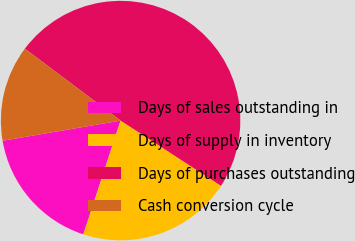Convert chart to OTSL. <chart><loc_0><loc_0><loc_500><loc_500><pie_chart><fcel>Days of sales outstanding in<fcel>Days of supply in inventory<fcel>Days of purchases outstanding<fcel>Cash conversion cycle<nl><fcel>17.27%<fcel>20.86%<fcel>48.92%<fcel>12.95%<nl></chart> 